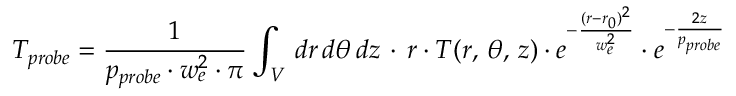<formula> <loc_0><loc_0><loc_500><loc_500>T _ { p r o b e } = \frac { 1 } { p _ { p r o b e } \cdot w _ { e } ^ { 2 } \cdot \pi } \int _ { V } \, d r \, d \theta \, d z \, \cdot \, r \cdot T ( r , \, \theta , \, z ) \cdot e ^ { - \frac { ( r - r _ { 0 } ) ^ { 2 } } { w _ { e } ^ { 2 } } } \cdot e ^ { - \frac { 2 z } { p _ { p r o b e } } }</formula> 